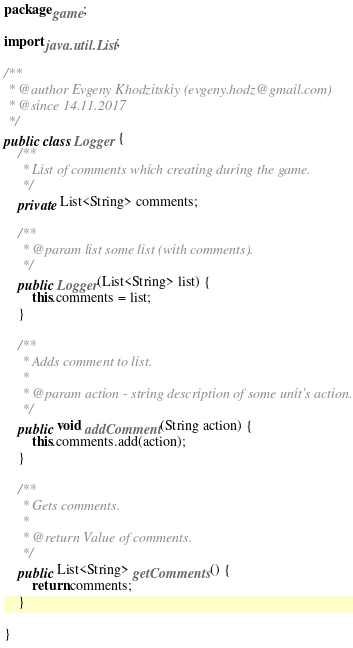Convert code to text. <code><loc_0><loc_0><loc_500><loc_500><_Java_>package game;

import java.util.List;

/**
 * @author Evgeny Khodzitskiy (evgeny.hodz@gmail.com)
 * @since 14.11.2017
 */
public class Logger {
    /**
     * List of comments which creating during the game.
     */
    private List<String> comments;

    /**
     * @param list some list (with comments).
     */
    public Logger(List<String> list) {
        this.comments = list;
    }

    /**
     * Adds comment to list.
     *
     * @param action - string description of some unit's action.
     */
    public void addComment(String action) {
        this.comments.add(action);
    }

    /**
     * Gets comments.
     *
     * @return Value of comments.
     */
    public List<String> getComments() {
        return comments;
    }

}
</code> 